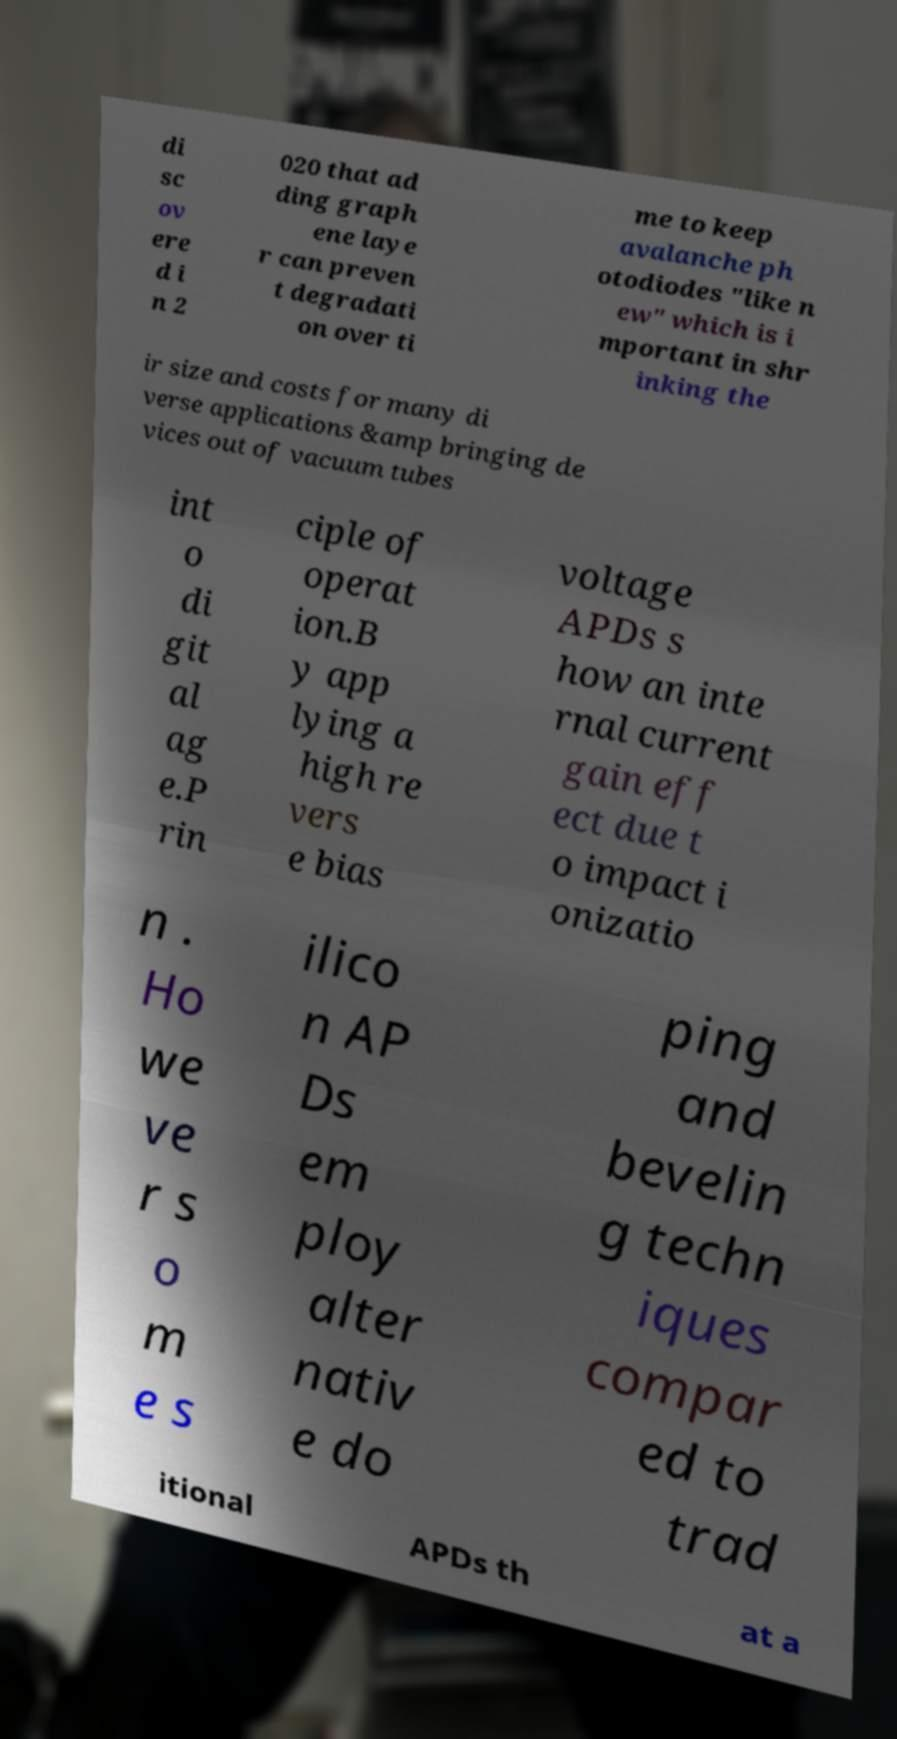Could you assist in decoding the text presented in this image and type it out clearly? di sc ov ere d i n 2 020 that ad ding graph ene laye r can preven t degradati on over ti me to keep avalanche ph otodiodes "like n ew" which is i mportant in shr inking the ir size and costs for many di verse applications &amp bringing de vices out of vacuum tubes int o di git al ag e.P rin ciple of operat ion.B y app lying a high re vers e bias voltage APDs s how an inte rnal current gain eff ect due t o impact i onizatio n . Ho we ve r s o m e s ilico n AP Ds em ploy alter nativ e do ping and bevelin g techn iques compar ed to trad itional APDs th at a 